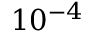<formula> <loc_0><loc_0><loc_500><loc_500>1 0 ^ { - 4 }</formula> 